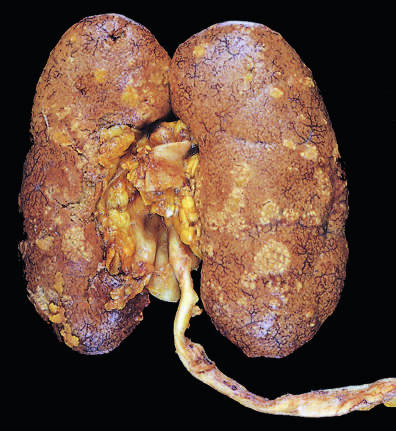s acute coronary throm-bosis studded with focal pale abscesses, more numerous in the upper pole and middle region of the kidney?
Answer the question using a single word or phrase. No 